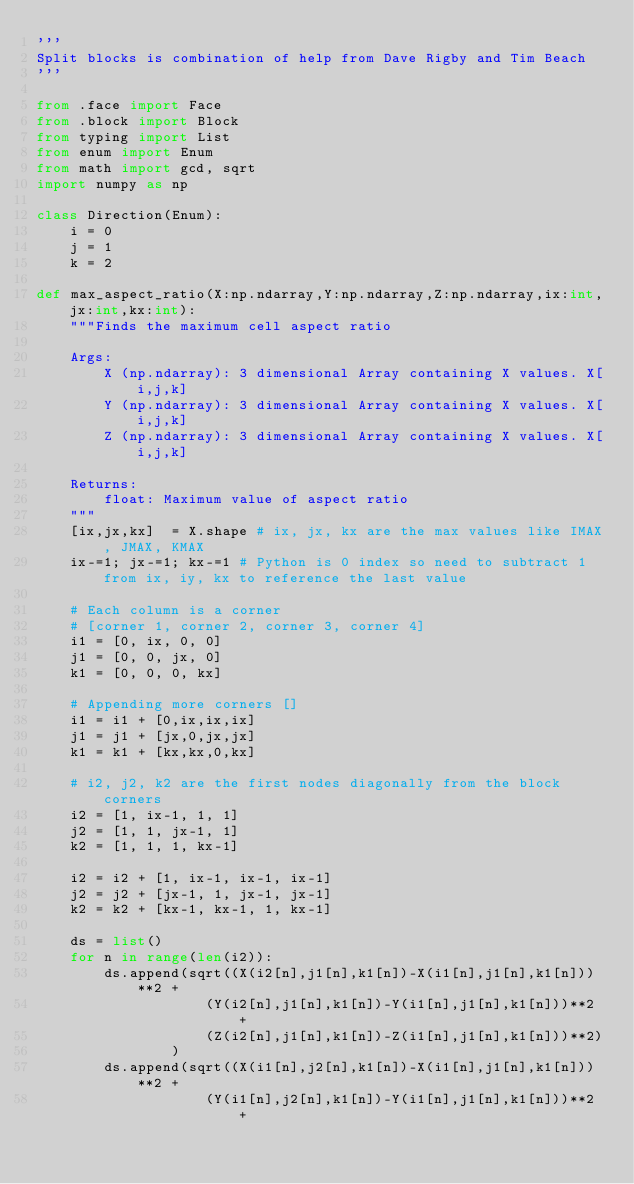<code> <loc_0><loc_0><loc_500><loc_500><_Python_>'''
Split blocks is combination of help from Dave Rigby and Tim Beach 
'''

from .face import Face
from .block import Block
from typing import List
from enum import Enum
from math import gcd, sqrt 
import numpy as np 

class Direction(Enum):
    i = 0
    j = 1
    k = 2

def max_aspect_ratio(X:np.ndarray,Y:np.ndarray,Z:np.ndarray,ix:int,jx:int,kx:int):
    """Finds the maximum cell aspect ratio

    Args:
        X (np.ndarray): 3 dimensional Array containing X values. X[i,j,k]
        Y (np.ndarray): 3 dimensional Array containing X values. X[i,j,k]
        Z (np.ndarray): 3 dimensional Array containing X values. X[i,j,k]

    Returns:
        float: Maximum value of aspect ratio 
    """
    [ix,jx,kx]  = X.shape # ix, jx, kx are the max values like IMAX, JMAX, KMAX
    ix-=1; jx-=1; kx-=1 # Python is 0 index so need to subtract 1 from ix, iy, kx to reference the last value 

    # Each column is a corner 
    # [corner 1, corner 2, corner 3, corner 4]
    i1 = [0, ix, 0, 0] 
    j1 = [0, 0, jx, 0]
    k1 = [0, 0, 0, kx]

    # Appending more corners []
    i1 = i1 + [0,ix,ix,ix]
    j1 = j1 + [jx,0,jx,jx]
    k1 = k1 + [kx,kx,0,kx]

    # i2, j2, k2 are the first nodes diagonally from the block corners 
    i2 = [1, ix-1, 1, 1]
    j2 = [1, 1, jx-1, 1]
    k2 = [1, 1, 1, kx-1]

    i2 = i2 + [1, ix-1, ix-1, ix-1]
    j2 = j2 + [jx-1, 1, jx-1, jx-1]
    k2 = k2 + [kx-1, kx-1, 1, kx-1]
    
    ds = list()
    for n in range(len(i2)):
        ds.append(sqrt((X(i2[n],j1[n],k1[n])-X(i1[n],j1[n],k1[n]))**2 +
                    (Y(i2[n],j1[n],k1[n])-Y(i1[n],j1[n],k1[n]))**2 +  
                    (Z(i2[n],j1[n],k1[n])-Z(i1[n],j1[n],k1[n]))**2)
                )
        ds.append(sqrt((X(i1[n],j2[n],k1[n])-X(i1[n],j1[n],k1[n]))**2 +  
                    (Y(i1[n],j2[n],k1[n])-Y(i1[n],j1[n],k1[n]))**2 +  </code> 